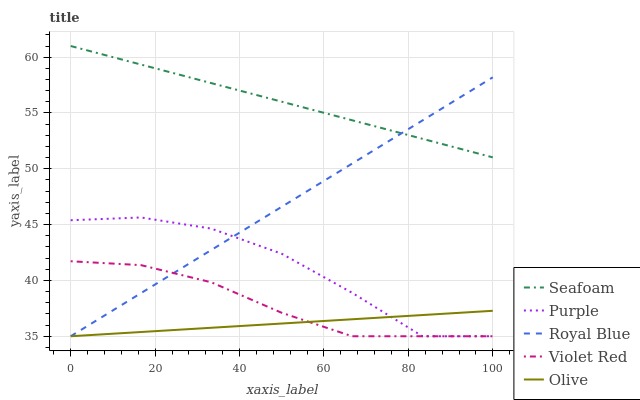Does Olive have the minimum area under the curve?
Answer yes or no. Yes. Does Seafoam have the maximum area under the curve?
Answer yes or no. Yes. Does Royal Blue have the minimum area under the curve?
Answer yes or no. No. Does Royal Blue have the maximum area under the curve?
Answer yes or no. No. Is Seafoam the smoothest?
Answer yes or no. Yes. Is Purple the roughest?
Answer yes or no. Yes. Is Royal Blue the smoothest?
Answer yes or no. No. Is Royal Blue the roughest?
Answer yes or no. No. Does Seafoam have the lowest value?
Answer yes or no. No. Does Seafoam have the highest value?
Answer yes or no. Yes. Does Royal Blue have the highest value?
Answer yes or no. No. Is Violet Red less than Seafoam?
Answer yes or no. Yes. Is Seafoam greater than Olive?
Answer yes or no. Yes. Does Violet Red intersect Royal Blue?
Answer yes or no. Yes. Is Violet Red less than Royal Blue?
Answer yes or no. No. Is Violet Red greater than Royal Blue?
Answer yes or no. No. Does Violet Red intersect Seafoam?
Answer yes or no. No. 